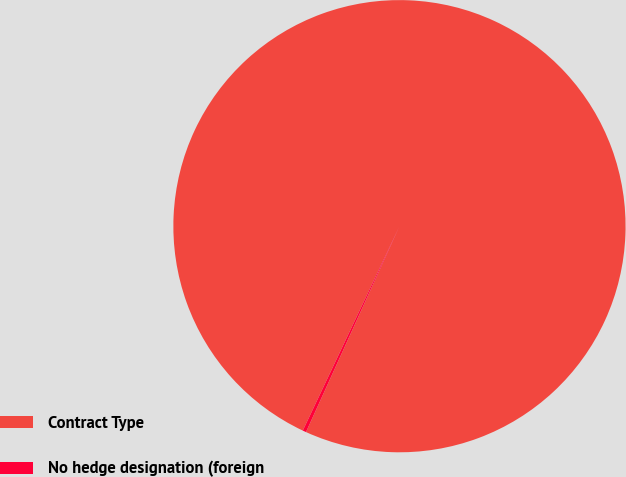Convert chart. <chart><loc_0><loc_0><loc_500><loc_500><pie_chart><fcel>Contract Type<fcel>No hedge designation (foreign<nl><fcel>99.75%<fcel>0.25%<nl></chart> 